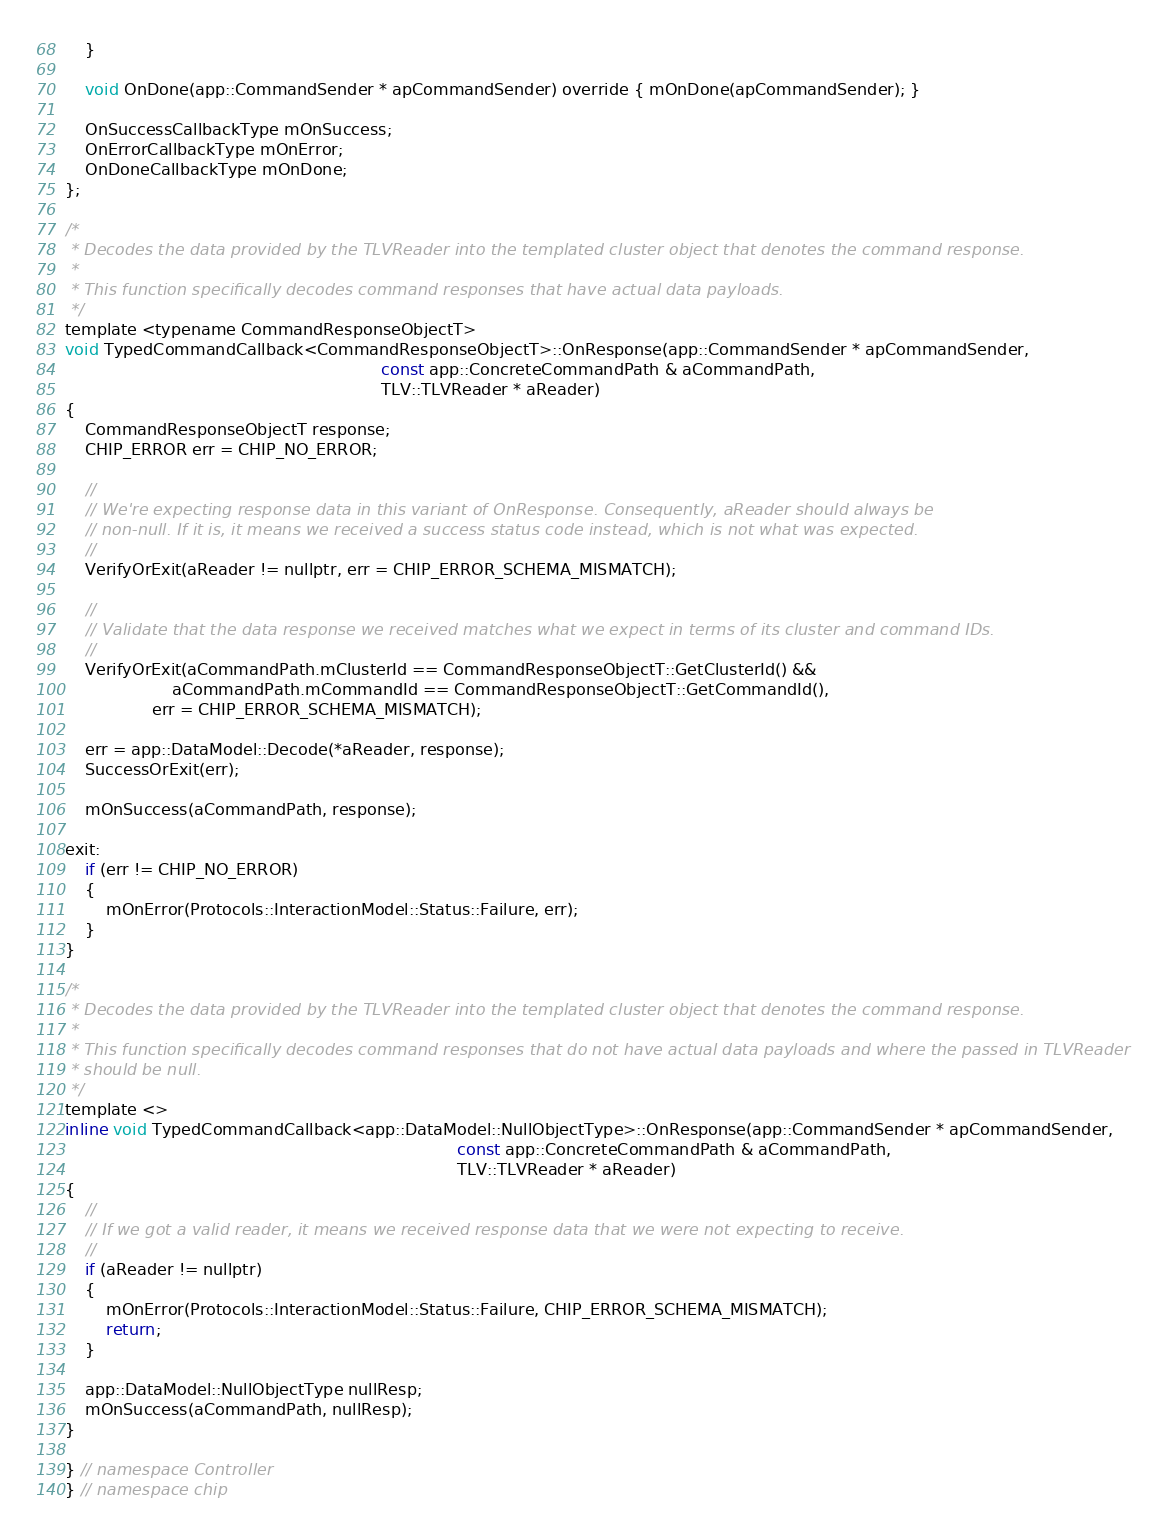Convert code to text. <code><loc_0><loc_0><loc_500><loc_500><_C_>    }

    void OnDone(app::CommandSender * apCommandSender) override { mOnDone(apCommandSender); }

    OnSuccessCallbackType mOnSuccess;
    OnErrorCallbackType mOnError;
    OnDoneCallbackType mOnDone;
};

/*
 * Decodes the data provided by the TLVReader into the templated cluster object that denotes the command response.
 *
 * This function specifically decodes command responses that have actual data payloads.
 */
template <typename CommandResponseObjectT>
void TypedCommandCallback<CommandResponseObjectT>::OnResponse(app::CommandSender * apCommandSender,
                                                              const app::ConcreteCommandPath & aCommandPath,
                                                              TLV::TLVReader * aReader)
{
    CommandResponseObjectT response;
    CHIP_ERROR err = CHIP_NO_ERROR;

    //
    // We're expecting response data in this variant of OnResponse. Consequently, aReader should always be
    // non-null. If it is, it means we received a success status code instead, which is not what was expected.
    //
    VerifyOrExit(aReader != nullptr, err = CHIP_ERROR_SCHEMA_MISMATCH);

    //
    // Validate that the data response we received matches what we expect in terms of its cluster and command IDs.
    //
    VerifyOrExit(aCommandPath.mClusterId == CommandResponseObjectT::GetClusterId() &&
                     aCommandPath.mCommandId == CommandResponseObjectT::GetCommandId(),
                 err = CHIP_ERROR_SCHEMA_MISMATCH);

    err = app::DataModel::Decode(*aReader, response);
    SuccessOrExit(err);

    mOnSuccess(aCommandPath, response);

exit:
    if (err != CHIP_NO_ERROR)
    {
        mOnError(Protocols::InteractionModel::Status::Failure, err);
    }
}

/*
 * Decodes the data provided by the TLVReader into the templated cluster object that denotes the command response.
 *
 * This function specifically decodes command responses that do not have actual data payloads and where the passed in TLVReader
 * should be null.
 */
template <>
inline void TypedCommandCallback<app::DataModel::NullObjectType>::OnResponse(app::CommandSender * apCommandSender,
                                                                             const app::ConcreteCommandPath & aCommandPath,
                                                                             TLV::TLVReader * aReader)
{
    //
    // If we got a valid reader, it means we received response data that we were not expecting to receive.
    //
    if (aReader != nullptr)
    {
        mOnError(Protocols::InteractionModel::Status::Failure, CHIP_ERROR_SCHEMA_MISMATCH);
        return;
    }

    app::DataModel::NullObjectType nullResp;
    mOnSuccess(aCommandPath, nullResp);
}

} // namespace Controller
} // namespace chip
</code> 